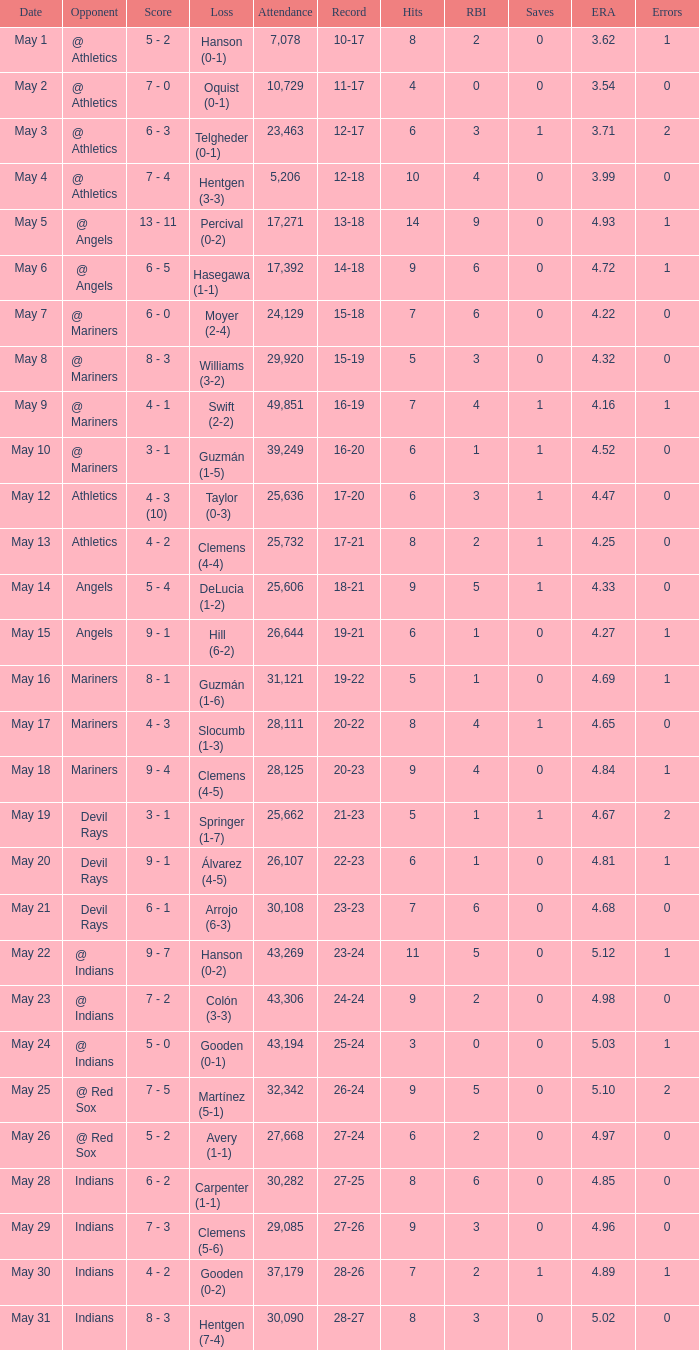When the record is 16-20 and attendance is greater than 32,342, what is the score? 3 - 1. 